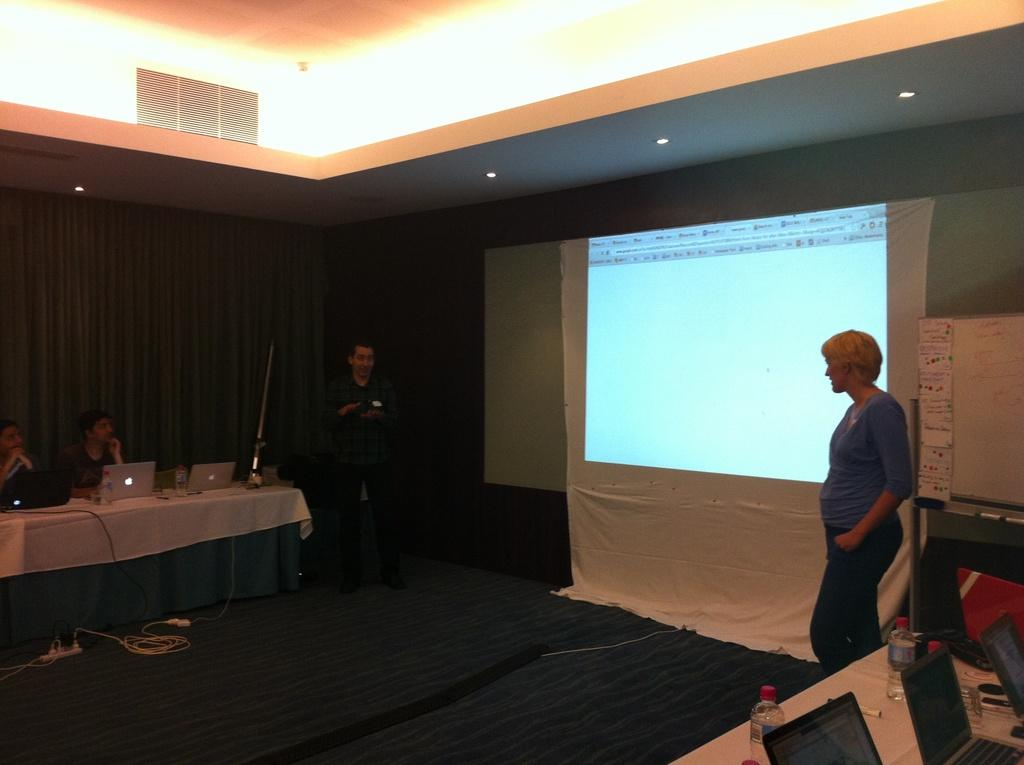What is on the wall in the image? There is a screen on the wall. How many people are standing in the image? Two persons are standing. What furniture is present in the image? There are tables and a chair in the image. What electronic devices are on the table? There are laptops on the table. What else is on the table besides laptops? There are bottles on the table. Is there a pest crawling on the screen in the image? There is no indication of a pest on the screen in the image. Can you tell me how many times the person sitting on the chair sneezes in the image? There is no person sneezing in the image; only a person sitting on a chair is present. 